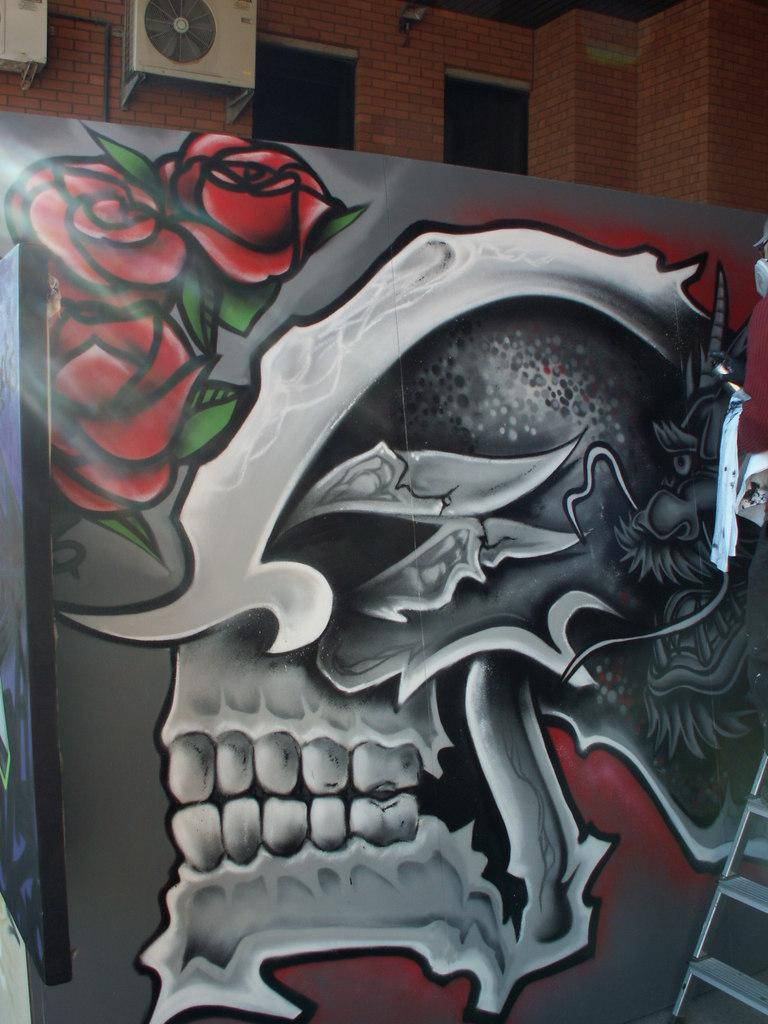What is depicted in the painting on the wall in the image? There is a painting of a skull and flowers on the wall in the image. What type of cooling system is present in the image? There is an outdoor AC in the image. On what type of surface is the outdoor AC placed? The outdoor AC is placed on a brick wall. What architectural feature can be seen in the image? There are windows visible in the image. How many feet are visible in the image? There are no feet present in the image. What type of vase is holding the flowers in the painting? The painting is a two-dimensional representation and does not show a vase holding the flowers. Is there a pig visible in the image? No, there is no pig present in the image. 